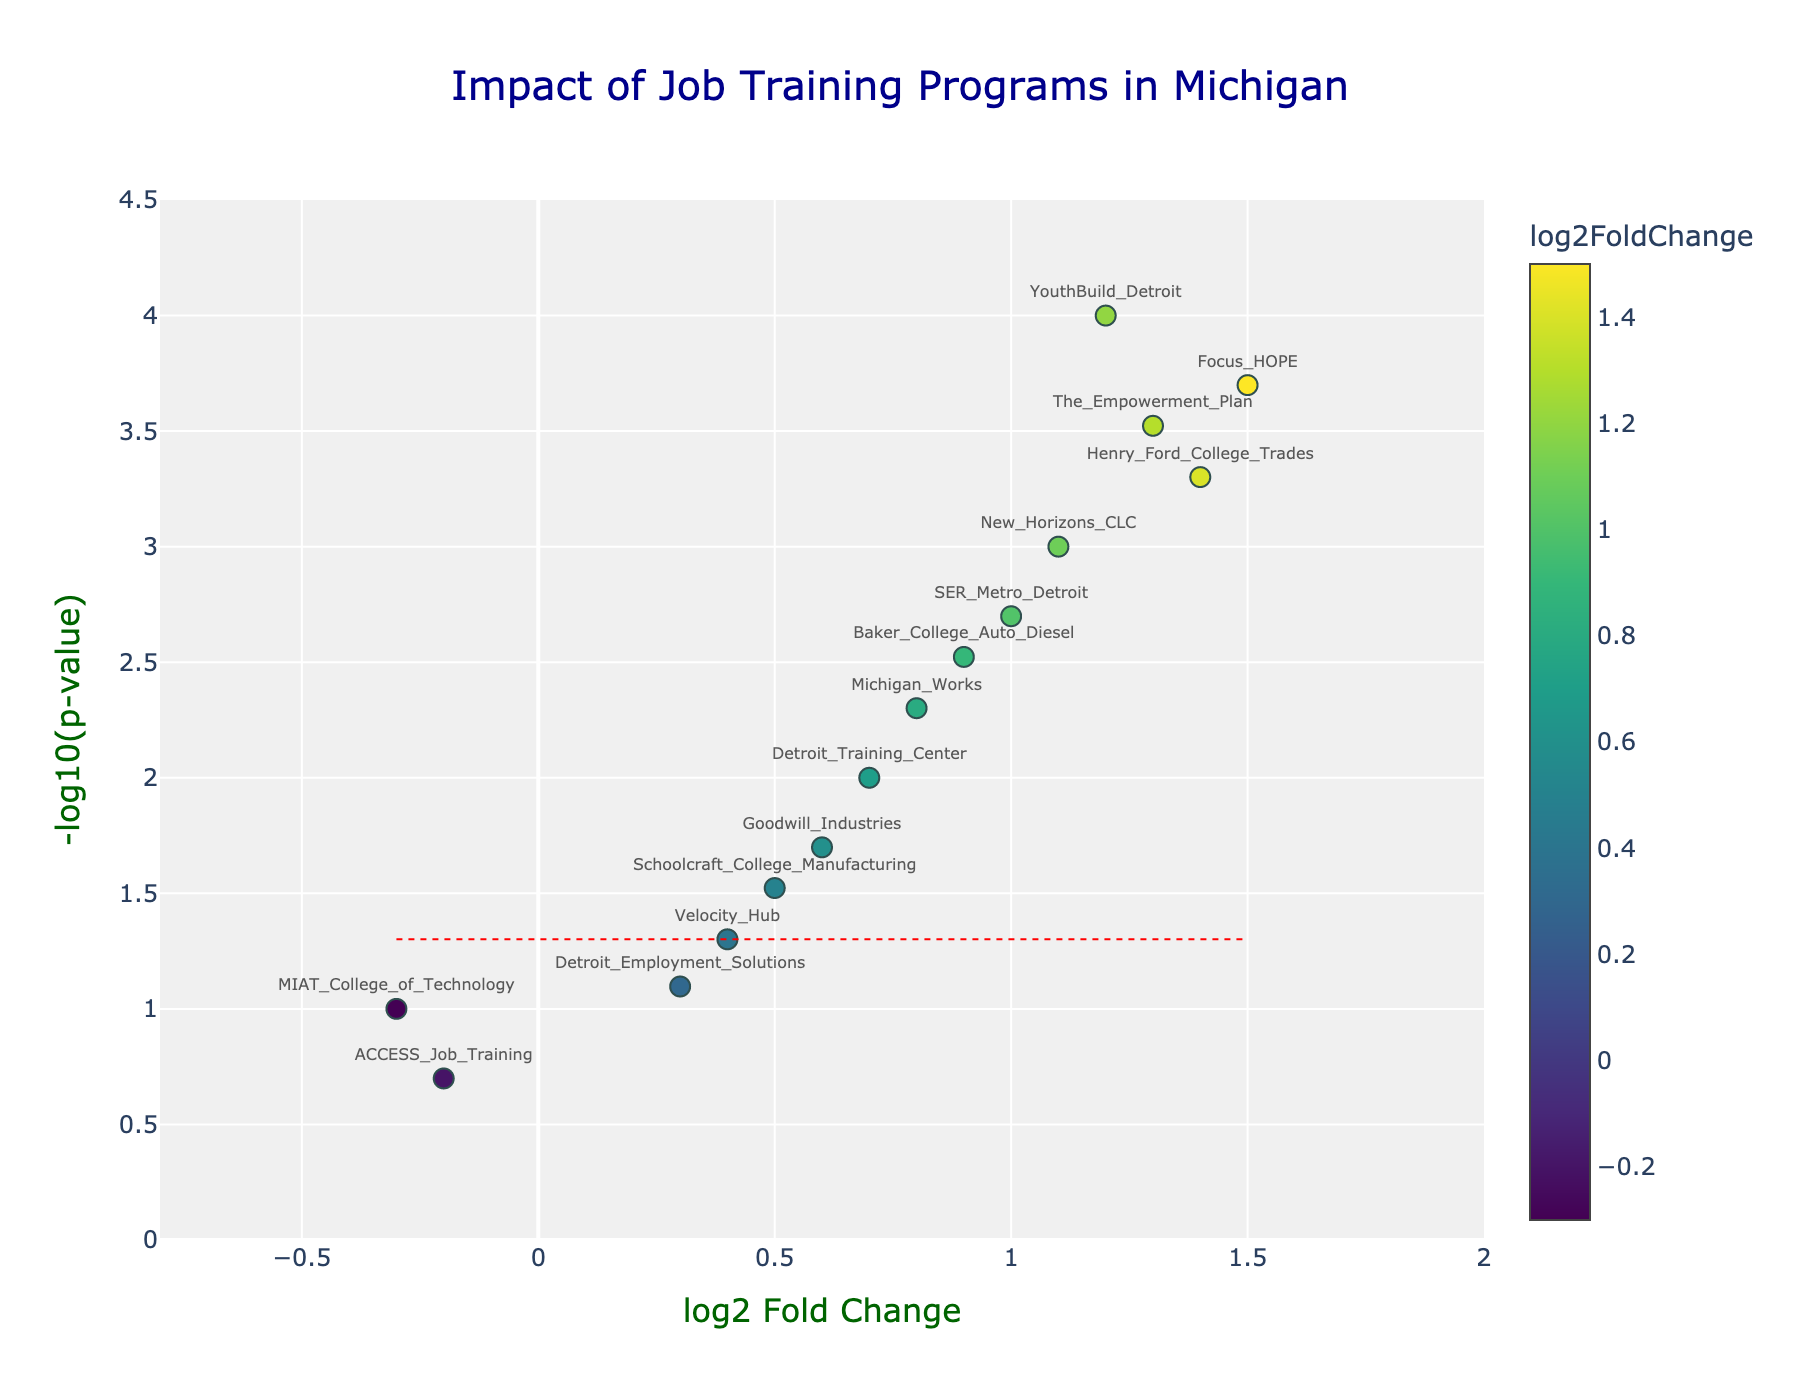What is the title of the chart? The title of the chart is typically displayed at the top, centered, and it is often in a prominent font to catch attention. In this case, it reads "Impact of Job Training Programs in Michigan."
Answer: Impact of Job Training Programs in Michigan What do the x-axis and y-axis represent? The x-axis represents the log2 Fold Change which indicates the change in employment rates and wage levels, while the y-axis represents -log10(p-value) indicating the statistical significance of those changes.
Answer: log2 Fold Change and -log10(p-value) How many programs have a log2 Fold Change greater than 1? By looking at the x-axis values, we count the data points to the right of the log2 Fold Change value of 1. These points are YouthBuild_Detroit, Focus_HOPE, The_Empowerment_Plan, and Henry_Ford_College_Trades. There are 4 programs in total.
Answer: 4 Which program has the highest -log10(p-value)? By looking at which data point is the highest on the y-axis, Focus_HOPE can be identified as having the highest -log10(p-value).
Answer: Focus_HOPE Are there any programs with log2 Fold Change less than 0? If so, which ones? By examining the x-axis, we identify the data points to the left of 0. These points are MIAT_College_of_Technology and ACCESS_Job_Training.
Answer: MIAT_College_of_Technology, ACCESS_Job_Training How many programs are statistically significant (p-value < 0.05)? To find statistically significant points, look at the data points above the horizontal line at -log10(0.05). Counting these points, we find YouthBuild_Detroit, Michigan_Works, Focus_HOPE, Goodwill_Industries, New_Horizons_CLC, Baker_College_Auto_Diesel, The_Empowerment_Plan, Detroit_Training_Center, SER_Metro_Detroit, and Henry_Ford_College_Trades, making a total of 10.
Answer: 10 Which program has the highest log2 Fold Change? By looking for the data point farthest to the right on the x-axis, we find Focus_HOPE has the highest log2 Fold Change.
Answer: Focus_HOPE Compare YouthBuild_Detroit and New_Horizons_CLC in terms of their p-values. Which one is more statistically significant? YouthBuild_Detroit's -log10(p-value) is higher than that of New_Horizons_CLC, indicating it is more statistically significant. Higher -log10(p-value) corresponds to a lower p-value.
Answer: YouthBuild_Detroit Which programs have both a log2 Fold Change above 0.5 and -log10(p-value) greater than 2? Programs need to be right of 0.5 on the x-axis and above 2 on the y-axis: YouthBuild_Detroit, Michigan_Works, Focus_HOPE, New_Horizons_CLC, Baker_College_Auto_Diesel, The_Empowerment_Plan, SER_Metro_Detroit, and Henry_Ford_College_Trades. There are 8 programs in total.
Answer: YouthBuild_Detroit, Michigan_Works, Focus_HOPE, New_Horizons_CLC, Baker_College_Auto_Diesel, The_Empowerment_Plan, SER_Metro_Detroit, Henry_Ford_College_Trades 